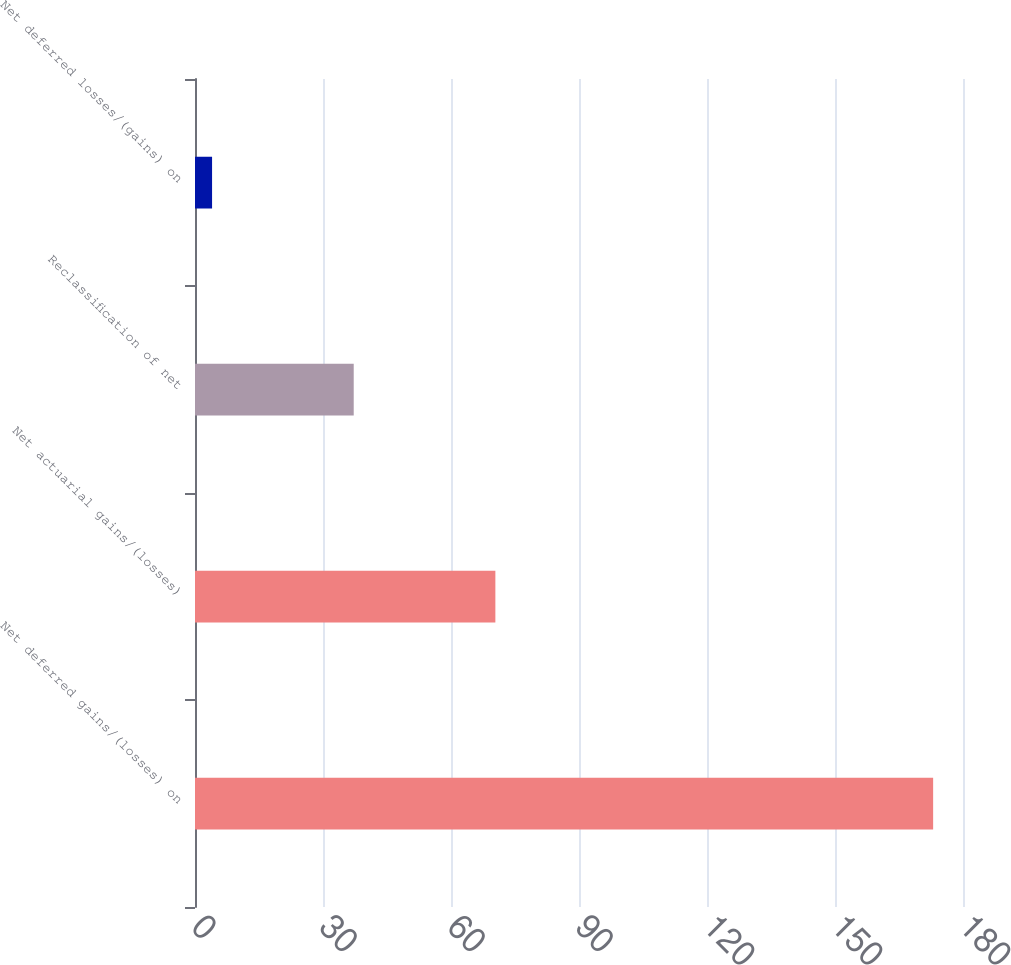Convert chart to OTSL. <chart><loc_0><loc_0><loc_500><loc_500><bar_chart><fcel>Net deferred gains/(losses) on<fcel>Net actuarial gains/(losses)<fcel>Reclassification of net<fcel>Net deferred losses/(gains) on<nl><fcel>173<fcel>70.4<fcel>37.2<fcel>4<nl></chart> 